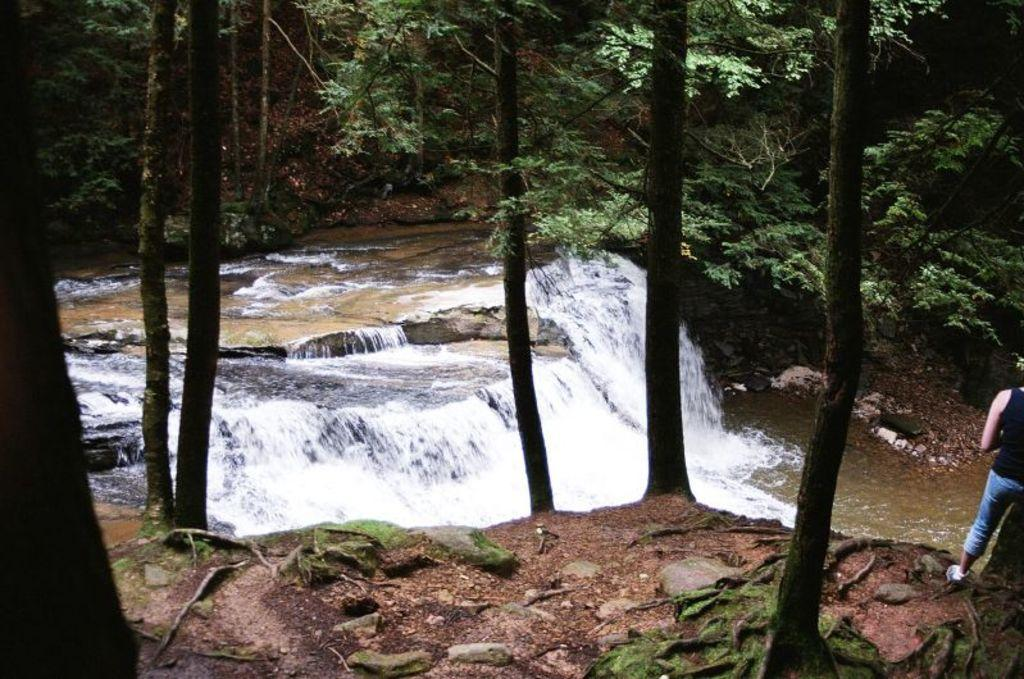What is the primary element visible in the image? There is water in the image. What type of vegetation can be seen in the image? There are trees in the image. Where is the person located in the image? The person is standing on the right side of the image. What type of cast can be seen on the person's arm in the image? There is no cast visible on the person's arm in the image. What type of substance is the person holding in the image? The image does not show the person holding any substance. 